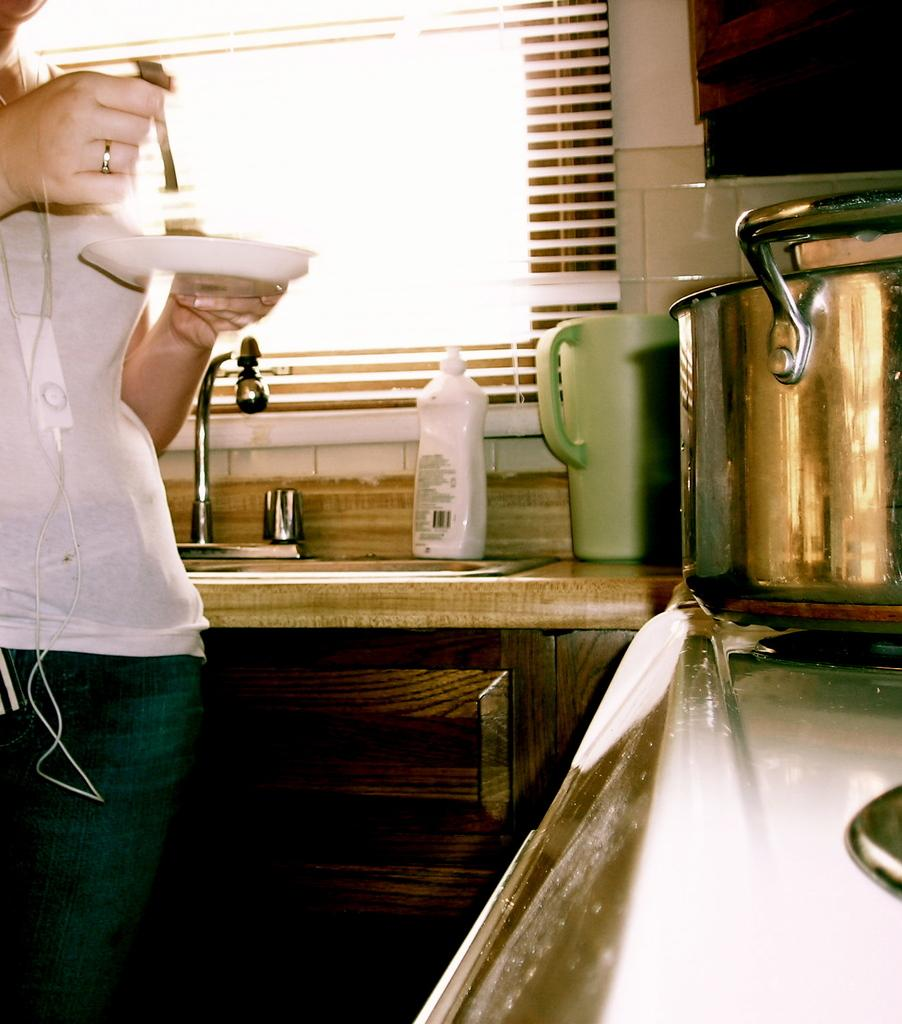What is the person in the image holding? The person is standing and holding a plate. What objects can be seen on the platform? There is a container, a mug, and a bottle on the platform. What appliance is present in the image? There is a stove in the image. Where is the sink located in the image? The sink with a tap is in front of a window. What type of cannon is being fired in the image? There is no cannon present in the image. Can you describe the smell of the popcorn in the image? There is no popcorn present in the image. 